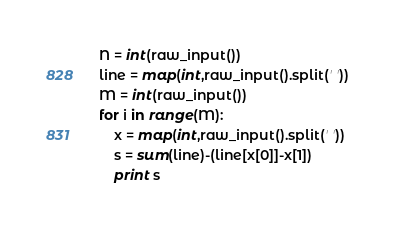Convert code to text. <code><loc_0><loc_0><loc_500><loc_500><_Python_>N = int(raw_input())
line = map(int,raw_input().split(' '))
M = int(raw_input())
for i in range(M):
    x = map(int,raw_input().split(' '))
    s = sum(line)-(line[x[0]]-x[1])
    print s
</code> 